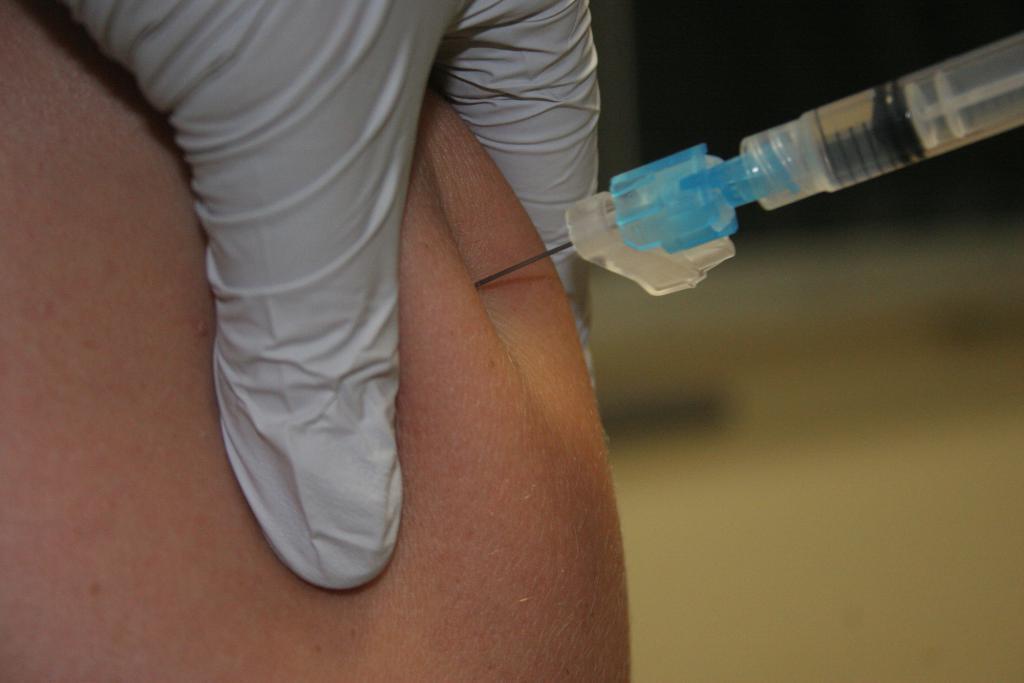Can you describe this image briefly? In the foreground of this picture, there is a person's hand and a injection needle in to the human's skin and the background is blurred. 